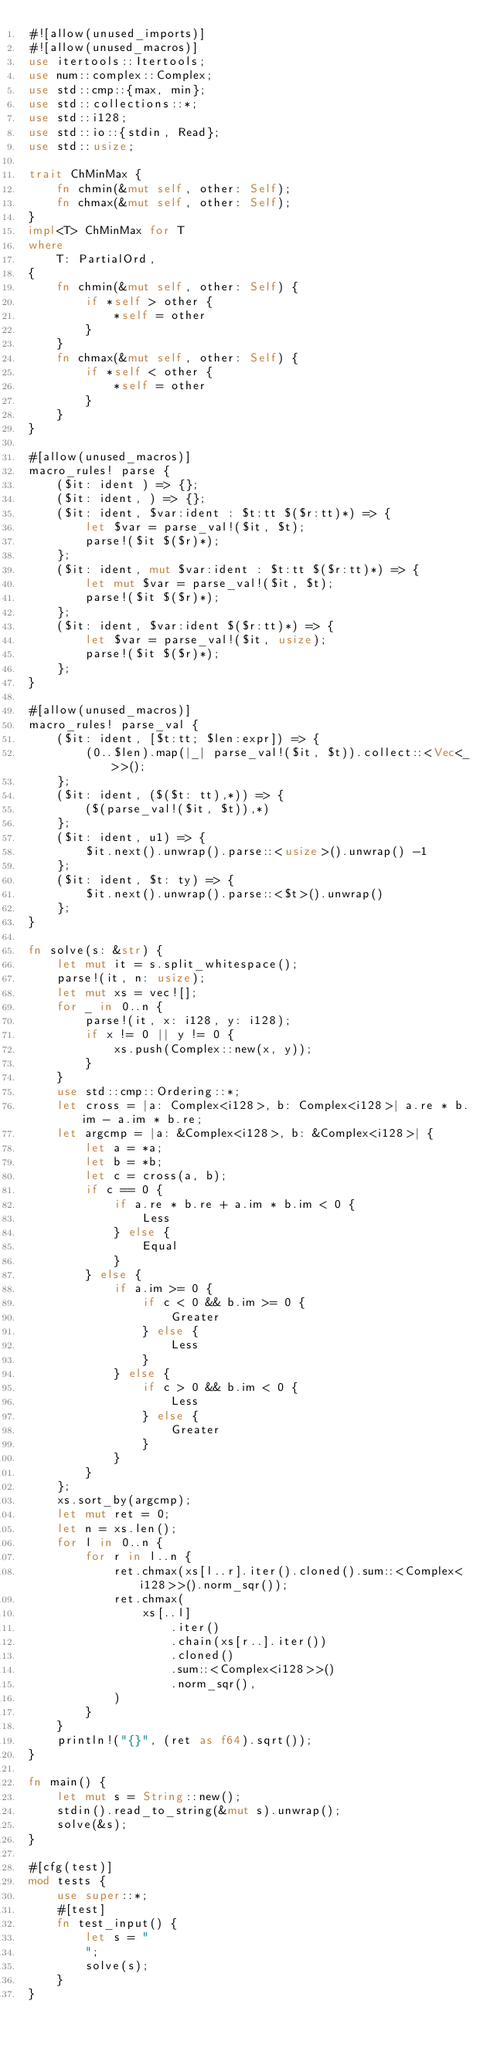Convert code to text. <code><loc_0><loc_0><loc_500><loc_500><_Rust_>#![allow(unused_imports)]
#![allow(unused_macros)]
use itertools::Itertools;
use num::complex::Complex;
use std::cmp::{max, min};
use std::collections::*;
use std::i128;
use std::io::{stdin, Read};
use std::usize;

trait ChMinMax {
    fn chmin(&mut self, other: Self);
    fn chmax(&mut self, other: Self);
}
impl<T> ChMinMax for T
where
    T: PartialOrd,
{
    fn chmin(&mut self, other: Self) {
        if *self > other {
            *self = other
        }
    }
    fn chmax(&mut self, other: Self) {
        if *self < other {
            *self = other
        }
    }
}

#[allow(unused_macros)]
macro_rules! parse {
    ($it: ident ) => {};
    ($it: ident, ) => {};
    ($it: ident, $var:ident : $t:tt $($r:tt)*) => {
        let $var = parse_val!($it, $t);
        parse!($it $($r)*);
    };
    ($it: ident, mut $var:ident : $t:tt $($r:tt)*) => {
        let mut $var = parse_val!($it, $t);
        parse!($it $($r)*);
    };
    ($it: ident, $var:ident $($r:tt)*) => {
        let $var = parse_val!($it, usize);
        parse!($it $($r)*);
    };
}

#[allow(unused_macros)]
macro_rules! parse_val {
    ($it: ident, [$t:tt; $len:expr]) => {
        (0..$len).map(|_| parse_val!($it, $t)).collect::<Vec<_>>();
    };
    ($it: ident, ($($t: tt),*)) => {
        ($(parse_val!($it, $t)),*)
    };
    ($it: ident, u1) => {
        $it.next().unwrap().parse::<usize>().unwrap() -1
    };
    ($it: ident, $t: ty) => {
        $it.next().unwrap().parse::<$t>().unwrap()
    };
}

fn solve(s: &str) {
    let mut it = s.split_whitespace();
    parse!(it, n: usize);
    let mut xs = vec![];
    for _ in 0..n {
        parse!(it, x: i128, y: i128);
        if x != 0 || y != 0 {
            xs.push(Complex::new(x, y));
        }
    }
    use std::cmp::Ordering::*;
    let cross = |a: Complex<i128>, b: Complex<i128>| a.re * b.im - a.im * b.re;
    let argcmp = |a: &Complex<i128>, b: &Complex<i128>| {
        let a = *a;
        let b = *b;
        let c = cross(a, b);
        if c == 0 {
            if a.re * b.re + a.im * b.im < 0 {
                Less
            } else {
                Equal
            }
        } else {
            if a.im >= 0 {
                if c < 0 && b.im >= 0 {
                    Greater
                } else {
                    Less
                }
            } else {
                if c > 0 && b.im < 0 {
                    Less
                } else {
                    Greater
                }
            }
        }
    };
    xs.sort_by(argcmp);
    let mut ret = 0;
    let n = xs.len();
    for l in 0..n {
        for r in l..n {
            ret.chmax(xs[l..r].iter().cloned().sum::<Complex<i128>>().norm_sqr());
            ret.chmax(
                xs[..l]
                    .iter()
                    .chain(xs[r..].iter())
                    .cloned()
                    .sum::<Complex<i128>>()
                    .norm_sqr(),
            )
        }
    }
    println!("{}", (ret as f64).sqrt());
}

fn main() {
    let mut s = String::new();
    stdin().read_to_string(&mut s).unwrap();
    solve(&s);
}

#[cfg(test)]
mod tests {
    use super::*;
    #[test]
    fn test_input() {
        let s = "
        ";
        solve(s);
    }
}
</code> 